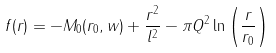<formula> <loc_0><loc_0><loc_500><loc_500>f ( r ) = - M _ { 0 } ( r _ { 0 } , w ) + \frac { r ^ { 2 } } { l ^ { 2 } } - \pi Q ^ { 2 } \ln \left ( \frac { r } { r _ { 0 } } \right )</formula> 